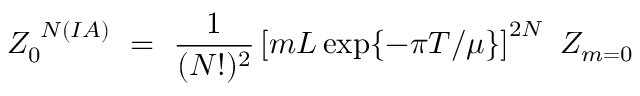<formula> <loc_0><loc_0><loc_500><loc_500>Z _ { 0 } ^ { N ( I A ) } = \frac { 1 } { ( N ! ) ^ { 2 } } \left [ m L \exp \{ - \pi T / \mu \} \right ] ^ { 2 N } Z _ { m = 0 }</formula> 